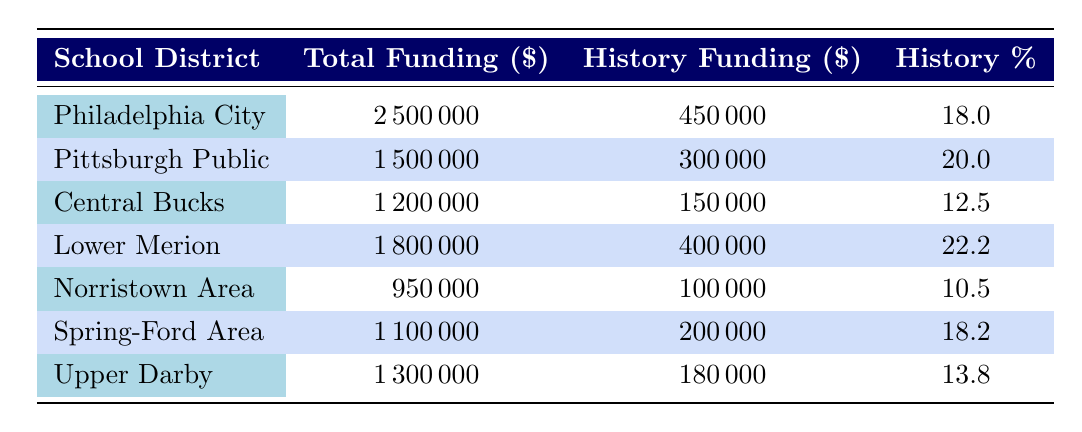What is the total funding for the Philadelphia City School District? The total funding for Philadelphia City School District is presented in the second column of the table, which shows a value of 2500000.
Answer: 2500000 Which school district has the highest percentage of funding for history education? The percentage of history funding for each district is shown in the fourth column. Lower Merion School District has the highest percentage at 22.2.
Answer: Lower Merion School District What is the total funding for history education in the Central Bucks School District? The table lists the history funding for Central Bucks School District in the third column, which indicates a funding amount of 150000.
Answer: 150000 Calculate the average percentage of history funding across all school districts listed. To find the average, sum the percentages of history funding (18 + 20 + 12.5 + 22.2 + 10.5 + 18.2 + 13.8) = 125.2. There are 7 districts, so the average percentage is 125.2 / 7 = 17.9.
Answer: 17.9 Is Norristown Area School District’s history funding percentage higher than 15%? The history funding percentage for Norristown Area School District is 10.5, which is less than 15%. Thus, the statement is false.
Answer: No How much more funding for history education does the Lower Merion School District receive compared to Norristown Area School District? The funding for history in Lower Merion is 400000, and for Norristown, it's 100000. The difference is 400000 - 100000 = 300000.
Answer: 300000 Which district has a total funding of 1100000, and what is its percentage of history funding? According to the table, Spring-Ford Area School District has a total funding of 1100000, and its percentage of history funding is 18.2.
Answer: Spring-Ford Area School District, 18.2 If we combine the funding for history in both the Pittsburgh Public Schools and Upper Darby School District, what would that total be? The history funding for Pittsburgh Public Schools is 300000, and for Upper Darby, it is 180000. Adding these amounts gives 300000 + 180000 = 480000.
Answer: 480000 